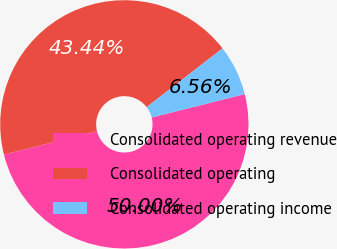<chart> <loc_0><loc_0><loc_500><loc_500><pie_chart><fcel>Consolidated operating revenue<fcel>Consolidated operating<fcel>Consolidated operating income<nl><fcel>50.0%<fcel>43.44%<fcel>6.56%<nl></chart> 